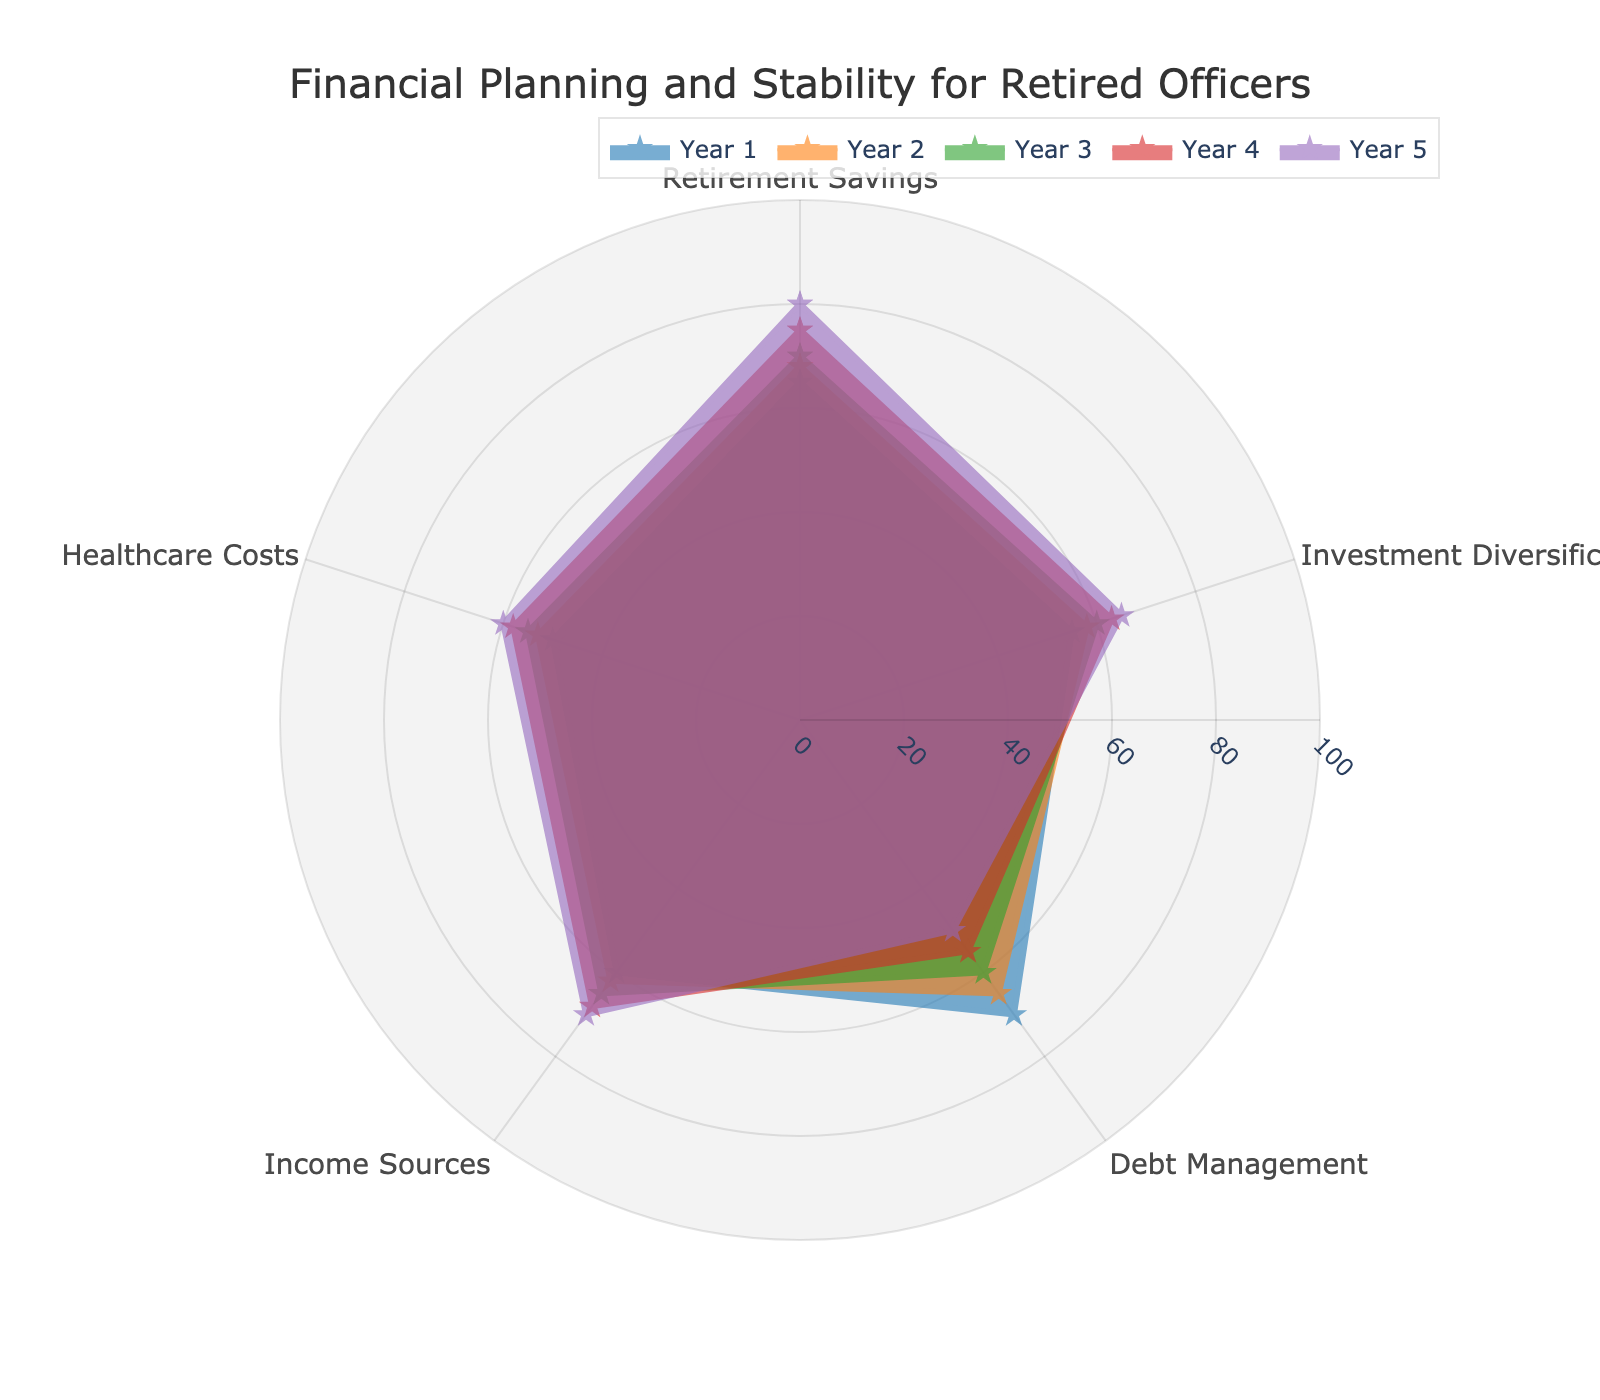What is the title of the radar chart? The title is typically displayed prominently at the top of the chart and provides an overview of the data it represents. In this case, it's mentioned in the code as the 'Financial Planning and Stability for Retired Officers'.
Answer: Financial Planning and Stability for Retired Officers How many categories are displayed in each year on the radar chart? The radar chart includes the categories as mentioned in the code: Retirement Savings, Investment Diversification, Debt Management, Income Sources, and Healthcare Costs.
Answer: 5 Which year shows the highest value in Retirement Savings? By examining the values for Retirement Savings across all years, we can see Year 5 has the highest value at 80.
Answer: Year 5 Compare the Debt Management of Year 1 and Year 5. Which year performs better? In Year 1, the value for Debt Management is 70, while in Year 5 it is 50. Thus, Year 1 performs better in Debt Management.
Answer: Year 1 What is the average value of Healthcare Costs over the five years? Summing the Healthcare Costs values from each year (50 + 53 + 55 + 58 + 60) gives 276, and dividing by the number of years (5) provides the average.
Answer: 55.2 Which category shows a continuous improvement over all five years? By assessing each category's values year by year, Retirement Savings shows consistent improvement (65, 68, 70, 75, 80).
Answer: Retirement Savings What is the overall pattern observed in Investment Diversification from Year 1 to Year 5? Examining the values (55, 58, 60, 63, 65) indicates a gradual, consistent increase in Investment Diversification over the five years.
Answer: Gradual increase In Year 3, which category has the lowest value? Reviewing all category values in Year 3, the lowest value is found in Debt Management, which is 60.
Answer: Debt Management Between Year 4 and Year 5, which category shows the largest improvement? Calculating the differences: Retirement Savings (+5), Investment Diversification (+2), Debt Management (-5), Income Sources (+2), Healthcare Costs (+2). Retirement Savings shows the largest improvement with +5.
Answer: Retirement Savings Which year has the most balanced financial planning, considering all categories are close to their mean value? By analyzing the data visually, Year 4 appears most balanced as the categories are fairly consistent in their values (75, 63, 55, 68, 58).
Answer: Year 4 